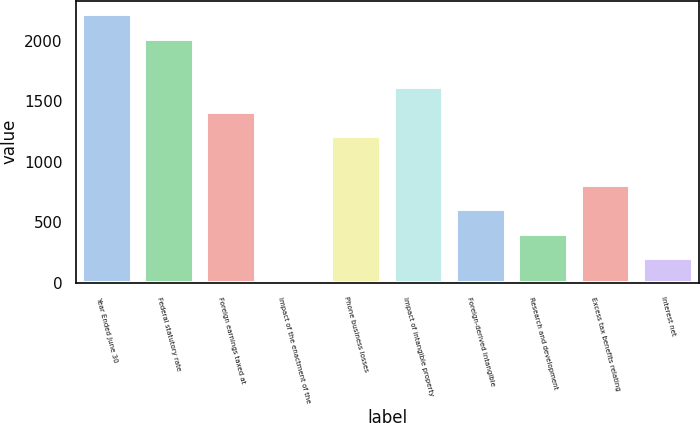<chart> <loc_0><loc_0><loc_500><loc_500><bar_chart><fcel>Year Ended June 30<fcel>Federal statutory rate<fcel>Foreign earnings taxed at<fcel>Impact of the enactment of the<fcel>Phone business losses<fcel>Impact of intangible property<fcel>Foreign-derived intangible<fcel>Research and development<fcel>Excess tax benefits relating<fcel>Interest net<nl><fcel>2220.86<fcel>2019<fcel>1413.42<fcel>0.4<fcel>1211.56<fcel>1615.28<fcel>605.98<fcel>404.12<fcel>807.84<fcel>202.26<nl></chart> 